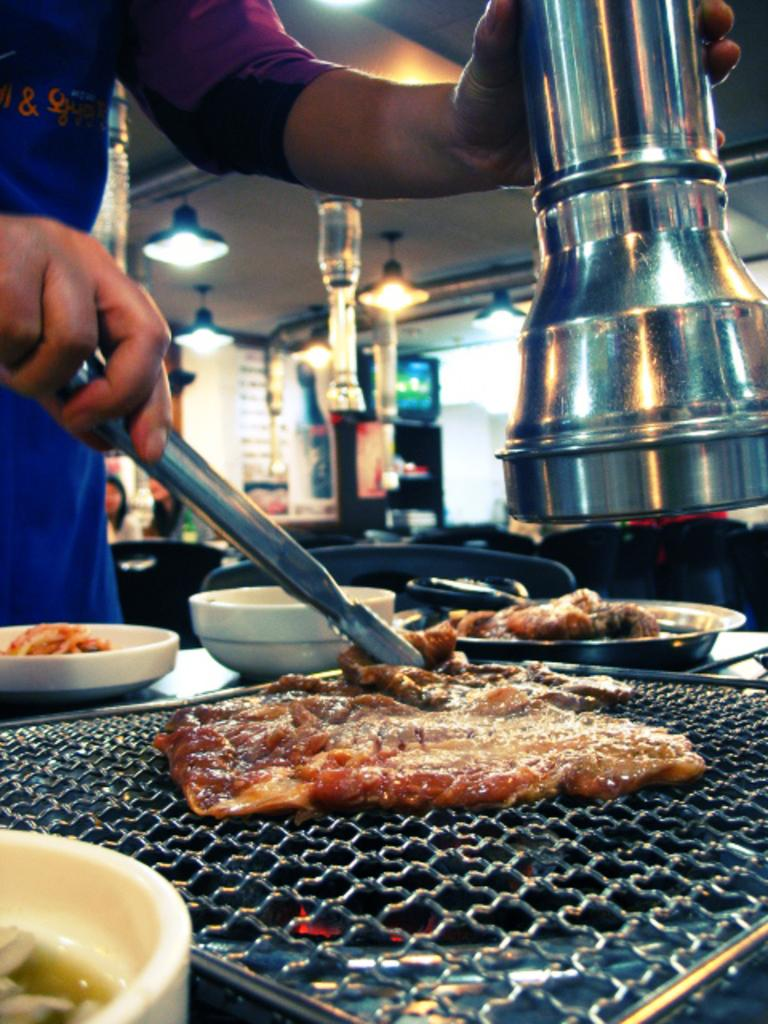What is the main subject of the image? There is a person in the image. What is the person holding in the image? The person is holding a tong. What can be seen cooking in the image? There is a food item on a grill. What type of containers are present in the image? There are bowls containing food items. What is illuminating the scene in the image? There are lights at the top of the image. What type of slope can be seen in the image? There is no slope present in the image. What is the purpose of the iron in the image? There is no iron present in the image. 